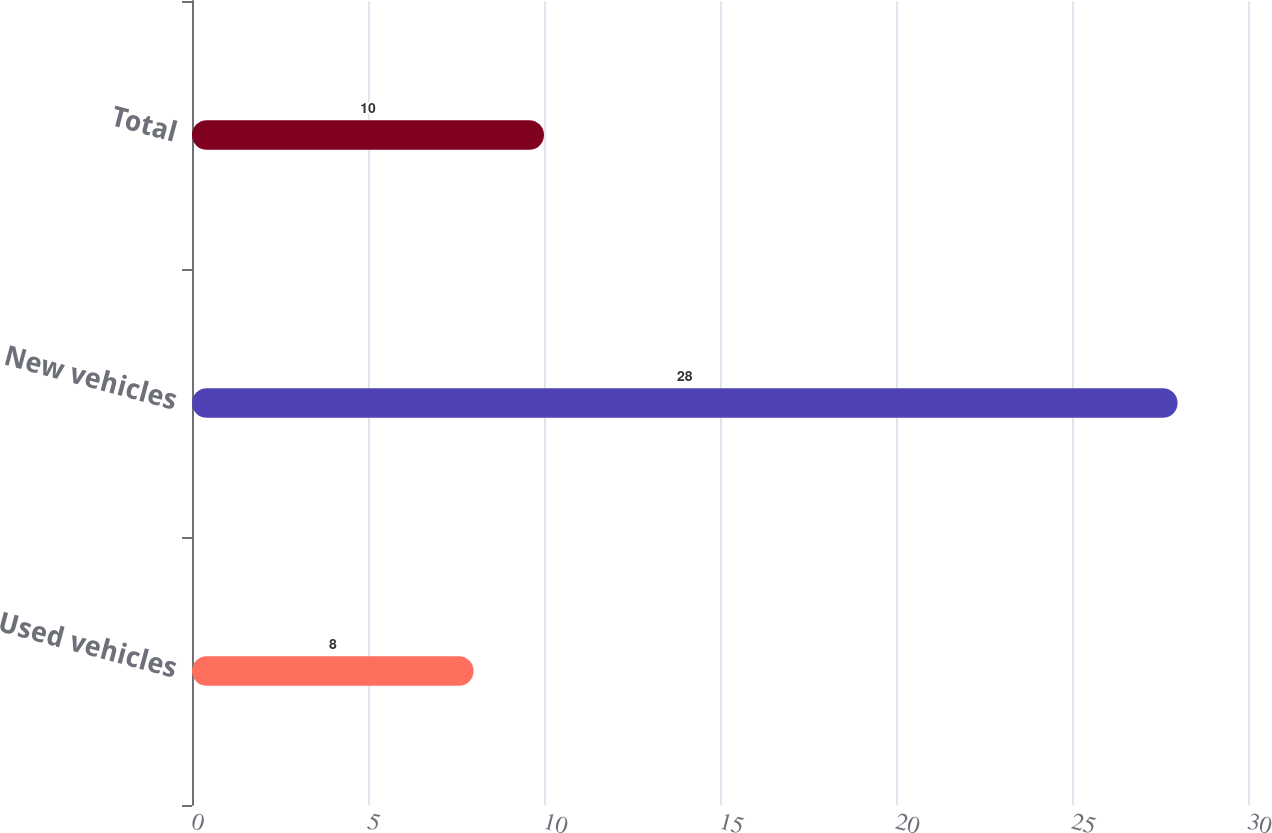<chart> <loc_0><loc_0><loc_500><loc_500><bar_chart><fcel>Used vehicles<fcel>New vehicles<fcel>Total<nl><fcel>8<fcel>28<fcel>10<nl></chart> 